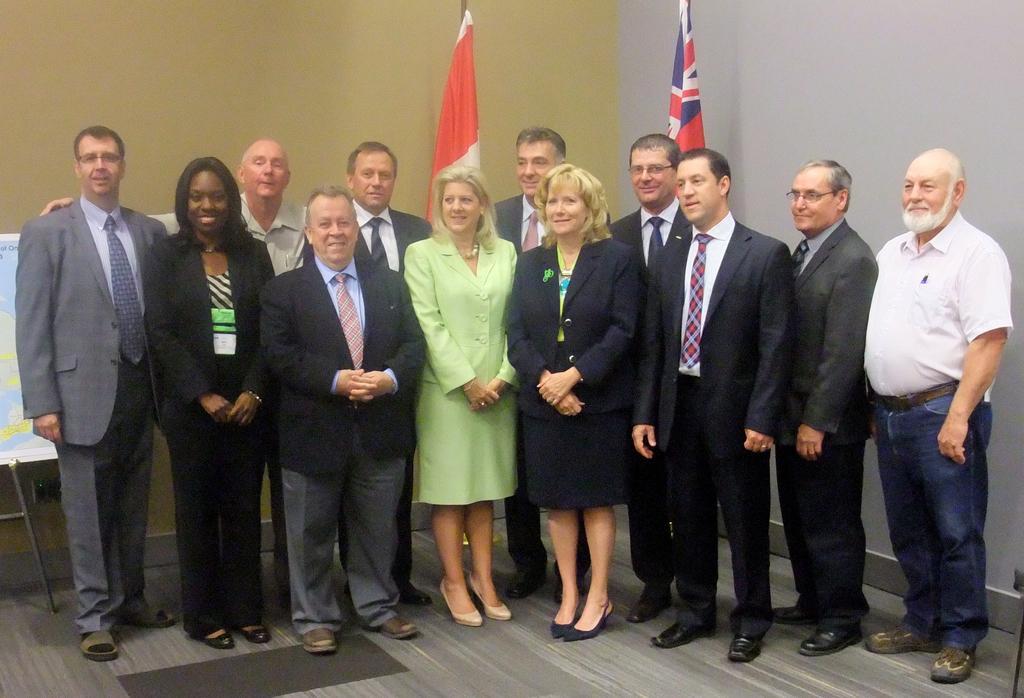Please provide a concise description of this image. In this image there are people standing on the floor. Behind them there are flags. To the left there is a board. There is a carpet on the floor. In the background there is a wall. 